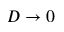Convert formula to latex. <formula><loc_0><loc_0><loc_500><loc_500>D \to 0</formula> 